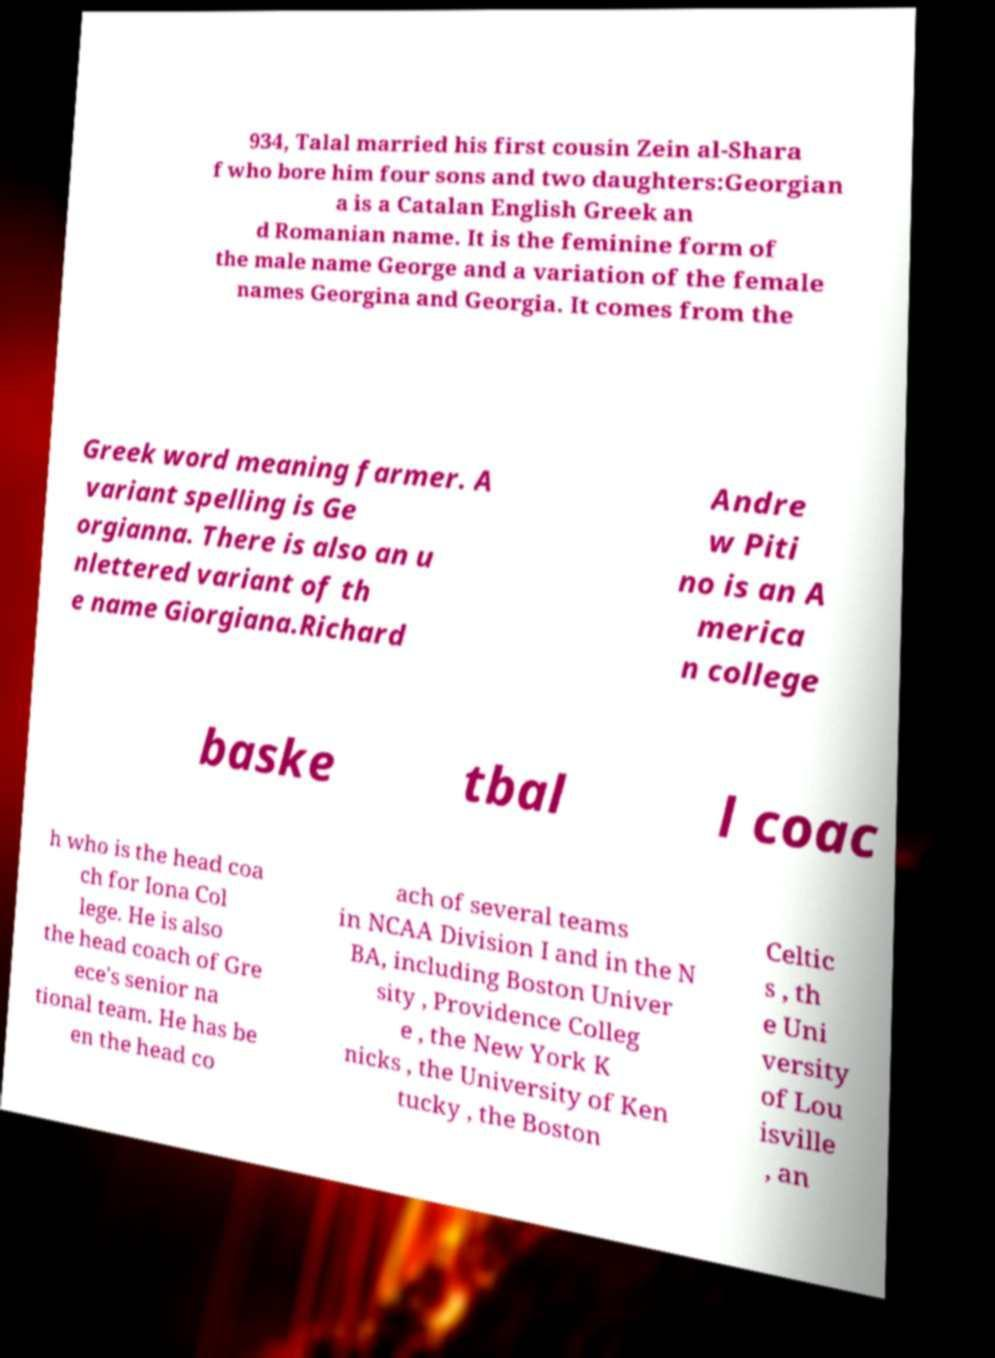Can you read and provide the text displayed in the image?This photo seems to have some interesting text. Can you extract and type it out for me? 934, Talal married his first cousin Zein al-Shara f who bore him four sons and two daughters:Georgian a is a Catalan English Greek an d Romanian name. It is the feminine form of the male name George and a variation of the female names Georgina and Georgia. It comes from the Greek word meaning farmer. A variant spelling is Ge orgianna. There is also an u nlettered variant of th e name Giorgiana.Richard Andre w Piti no is an A merica n college baske tbal l coac h who is the head coa ch for Iona Col lege. He is also the head coach of Gre ece's senior na tional team. He has be en the head co ach of several teams in NCAA Division I and in the N BA, including Boston Univer sity , Providence Colleg e , the New York K nicks , the University of Ken tucky , the Boston Celtic s , th e Uni versity of Lou isville , an 